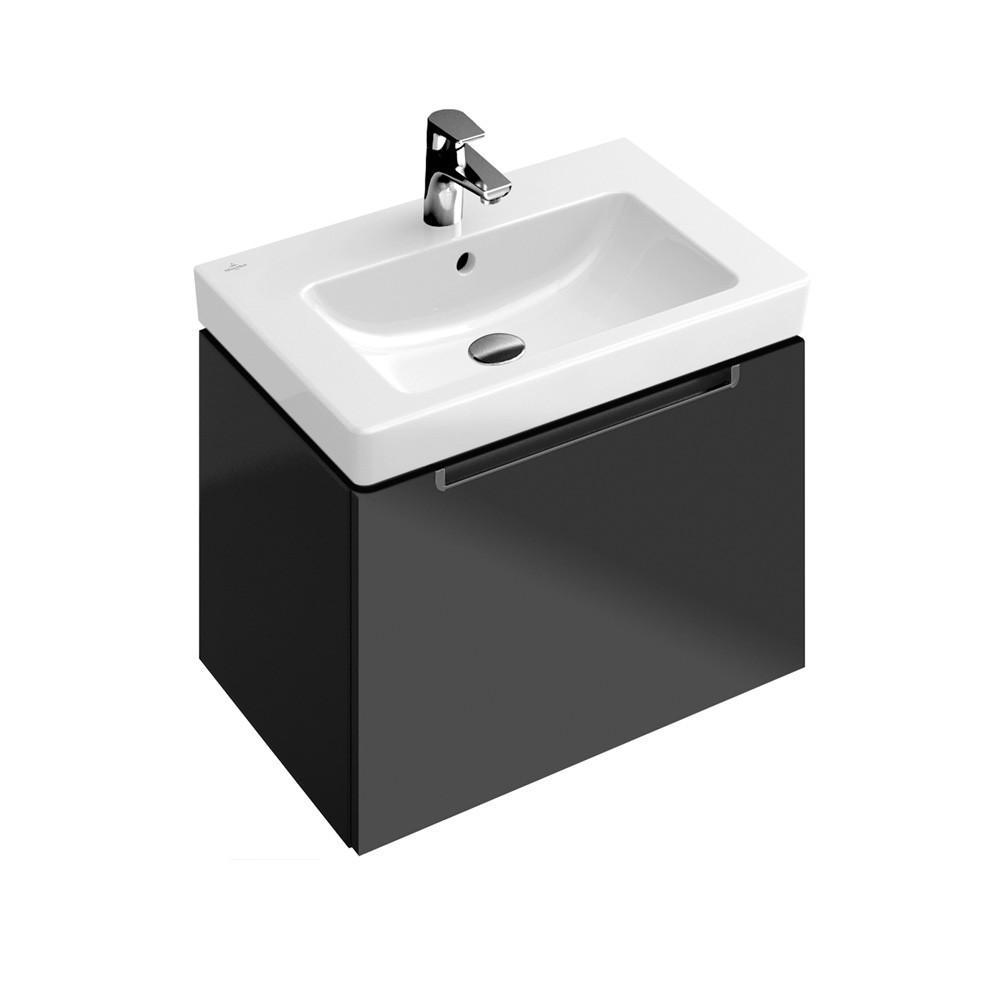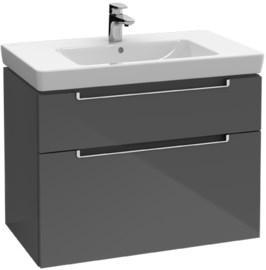The first image is the image on the left, the second image is the image on the right. Considering the images on both sides, is "Three faucets are visible." valid? Answer yes or no. No. The first image is the image on the left, the second image is the image on the right. Given the left and right images, does the statement "There are three faucets." hold true? Answer yes or no. No. 